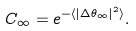<formula> <loc_0><loc_0><loc_500><loc_500>C _ { \infty } = e ^ { - \langle | \Delta \theta _ { \infty } | ^ { 2 } \rangle } .</formula> 